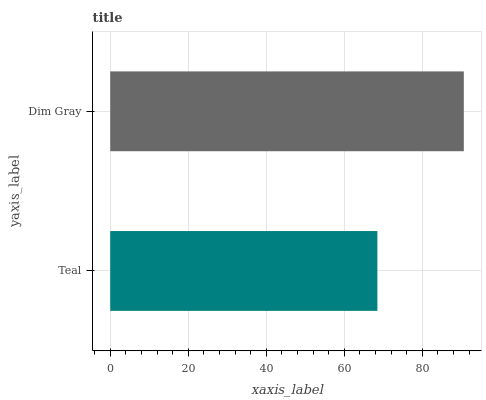Is Teal the minimum?
Answer yes or no. Yes. Is Dim Gray the maximum?
Answer yes or no. Yes. Is Dim Gray the minimum?
Answer yes or no. No. Is Dim Gray greater than Teal?
Answer yes or no. Yes. Is Teal less than Dim Gray?
Answer yes or no. Yes. Is Teal greater than Dim Gray?
Answer yes or no. No. Is Dim Gray less than Teal?
Answer yes or no. No. Is Dim Gray the high median?
Answer yes or no. Yes. Is Teal the low median?
Answer yes or no. Yes. Is Teal the high median?
Answer yes or no. No. Is Dim Gray the low median?
Answer yes or no. No. 